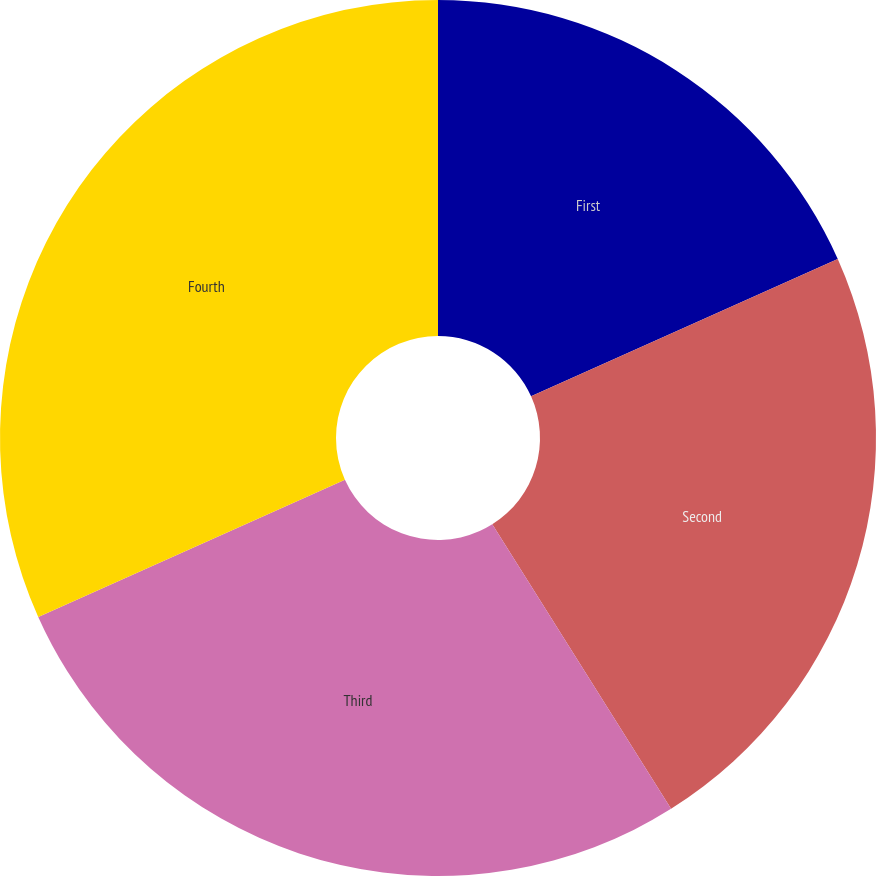<chart> <loc_0><loc_0><loc_500><loc_500><pie_chart><fcel>First<fcel>Second<fcel>Third<fcel>Fourth<nl><fcel>18.3%<fcel>22.77%<fcel>27.23%<fcel>31.7%<nl></chart> 